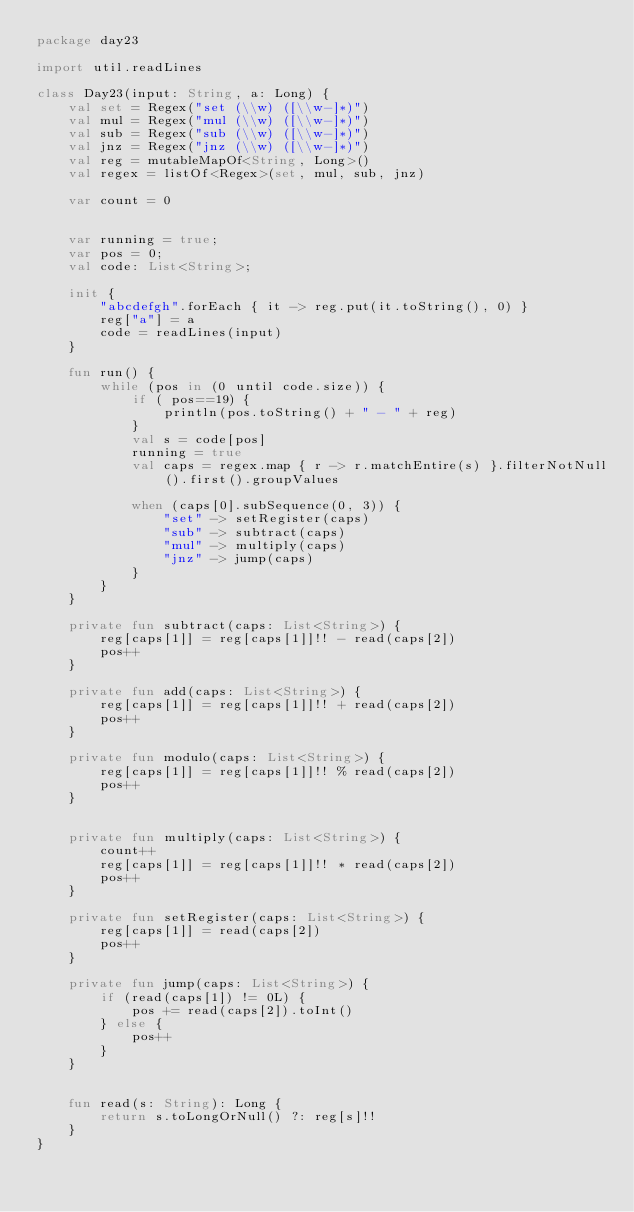<code> <loc_0><loc_0><loc_500><loc_500><_Kotlin_>package day23

import util.readLines

class Day23(input: String, a: Long) {
    val set = Regex("set (\\w) ([\\w-]*)")
    val mul = Regex("mul (\\w) ([\\w-]*)")
    val sub = Regex("sub (\\w) ([\\w-]*)")
    val jnz = Regex("jnz (\\w) ([\\w-]*)")
    val reg = mutableMapOf<String, Long>()
    val regex = listOf<Regex>(set, mul, sub, jnz)

    var count = 0


    var running = true;
    var pos = 0;
    val code: List<String>;

    init {
        "abcdefgh".forEach { it -> reg.put(it.toString(), 0) }
        reg["a"] = a
        code = readLines(input)
    }

    fun run() {
        while (pos in (0 until code.size)) {
            if ( pos==19) {
                println(pos.toString() + " - " + reg)
            }
            val s = code[pos]
            running = true
            val caps = regex.map { r -> r.matchEntire(s) }.filterNotNull().first().groupValues

            when (caps[0].subSequence(0, 3)) {
                "set" -> setRegister(caps)
                "sub" -> subtract(caps)
                "mul" -> multiply(caps)
                "jnz" -> jump(caps)
            }
        }
    }

    private fun subtract(caps: List<String>) {
        reg[caps[1]] = reg[caps[1]]!! - read(caps[2])
        pos++
    }

    private fun add(caps: List<String>) {
        reg[caps[1]] = reg[caps[1]]!! + read(caps[2])
        pos++
    }

    private fun modulo(caps: List<String>) {
        reg[caps[1]] = reg[caps[1]]!! % read(caps[2])
        pos++
    }


    private fun multiply(caps: List<String>) {
        count++
        reg[caps[1]] = reg[caps[1]]!! * read(caps[2])
        pos++
    }

    private fun setRegister(caps: List<String>) {
        reg[caps[1]] = read(caps[2])
        pos++
    }

    private fun jump(caps: List<String>) {
        if (read(caps[1]) != 0L) {
            pos += read(caps[2]).toInt()
        } else {
            pos++
        }
    }


    fun read(s: String): Long {
        return s.toLongOrNull() ?: reg[s]!!
    }
}</code> 